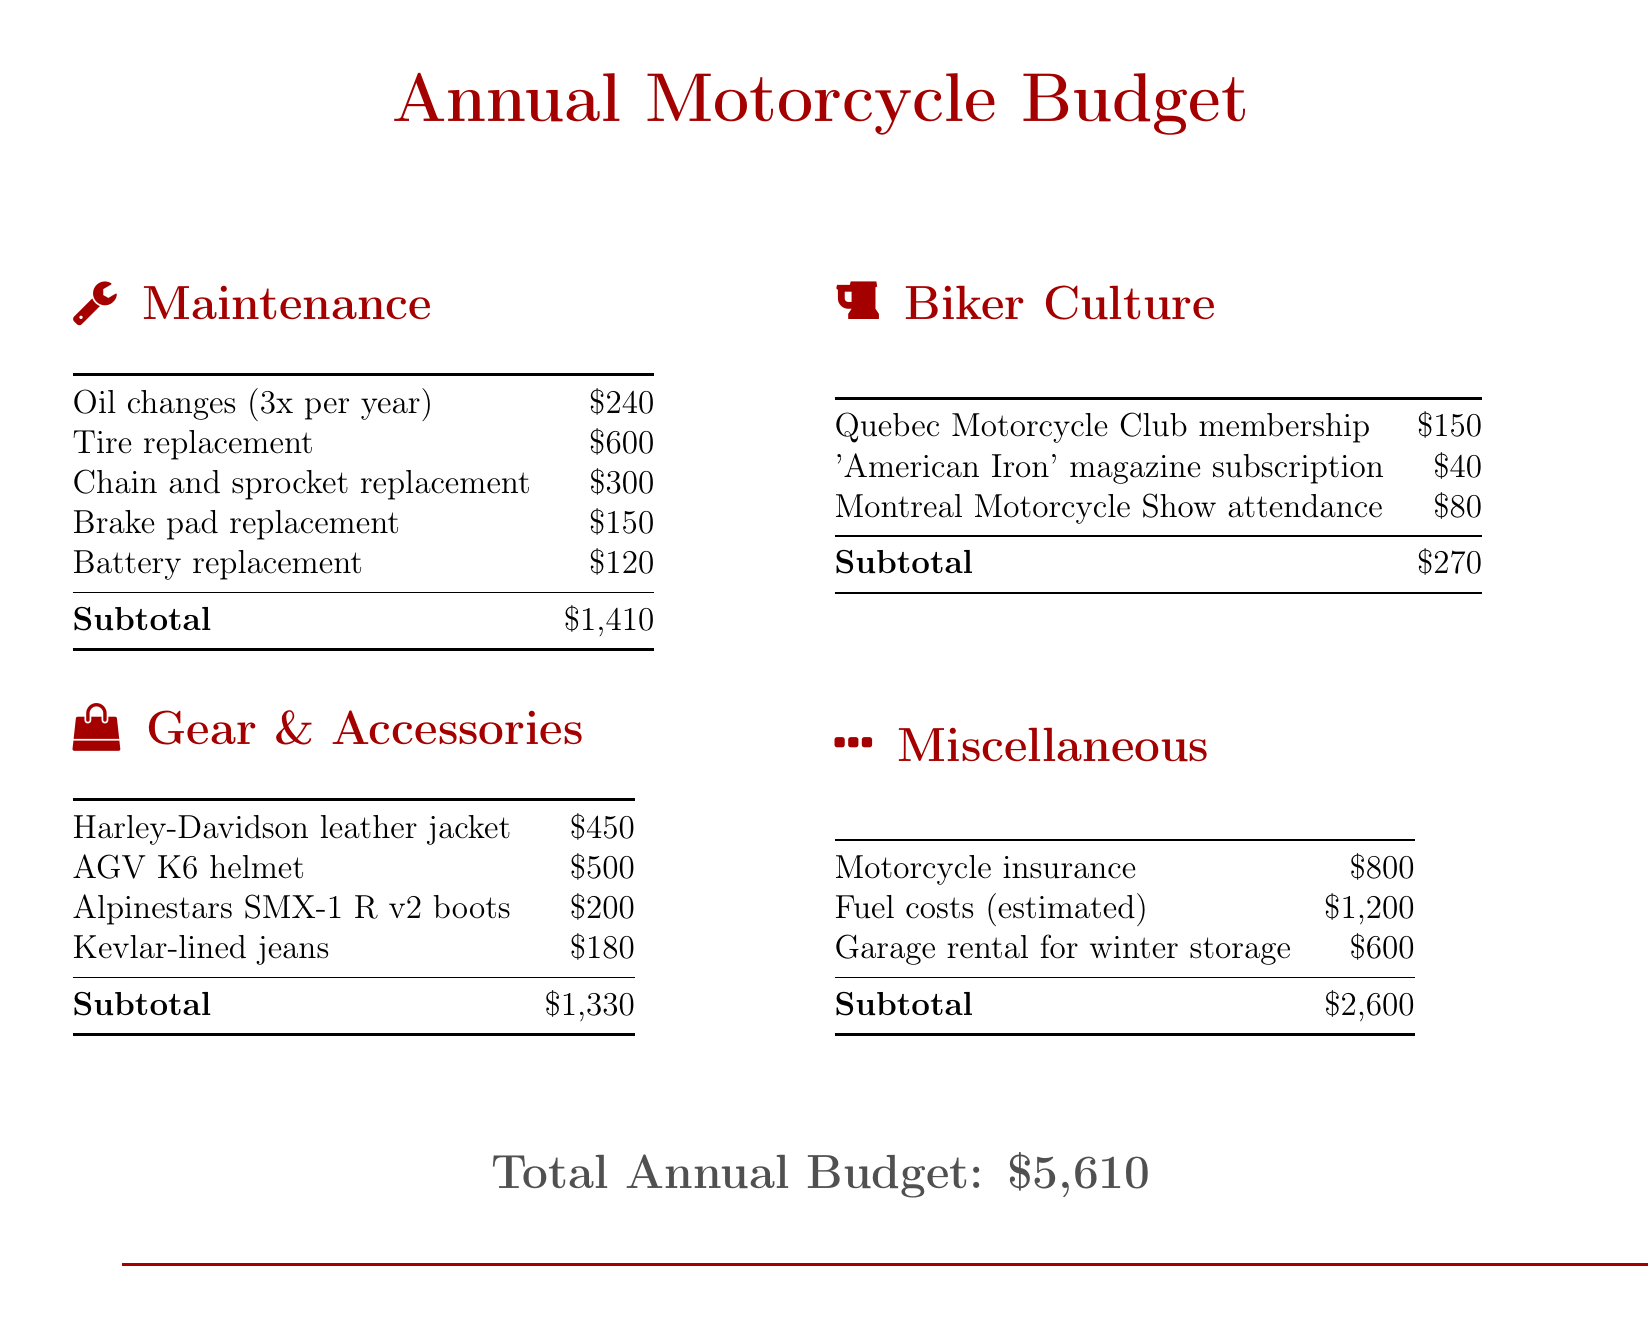What is the total annual budget? The total annual budget is presented at the bottom of the document as the sum of all listed expenses.
Answer: $5,610 How much is allocated for oil changes? The budget item for oil changes is specified in the maintenance section, showing the total cost for three oil changes per year.
Answer: $240 What is the cost of the Harley-Davidson leather jacket? The cost of the Harley-Davidson leather jacket is explicitly mentioned in the gear and accessories section.
Answer: $450 How many events or subscriptions are listed under biker culture expenses? The biker culture section lists three specific expenses related to membership, subscriptions, and event attendance.
Answer: 3 What is the subtotal for miscellaneous expenses? The subtotal for miscellaneous expenses is calculated by adding together motorcycle insurance, fuel costs, and garage rental expenses as shown in the corresponding table.
Answer: $2,600 What is the cost for tire replacement? The tire replacement cost is provided in the maintenance section as one of the expenses.
Answer: $600 What is the total spending on gear and accessories? The subsection for gear and accessories provides a subtotal that combines all listed gear-related expenses.
Answer: $1,330 How much is the Quebec Motorcycle Club membership? The document specifies the cost for membership in the Quebec Motorcycle Club under the biker culture section.
Answer: $150 What type of item is the 'American Iron' magazine? This item is categorized under biker culture and refers to a magazine subscription expense as per the document’s organization.
Answer: Subscription 